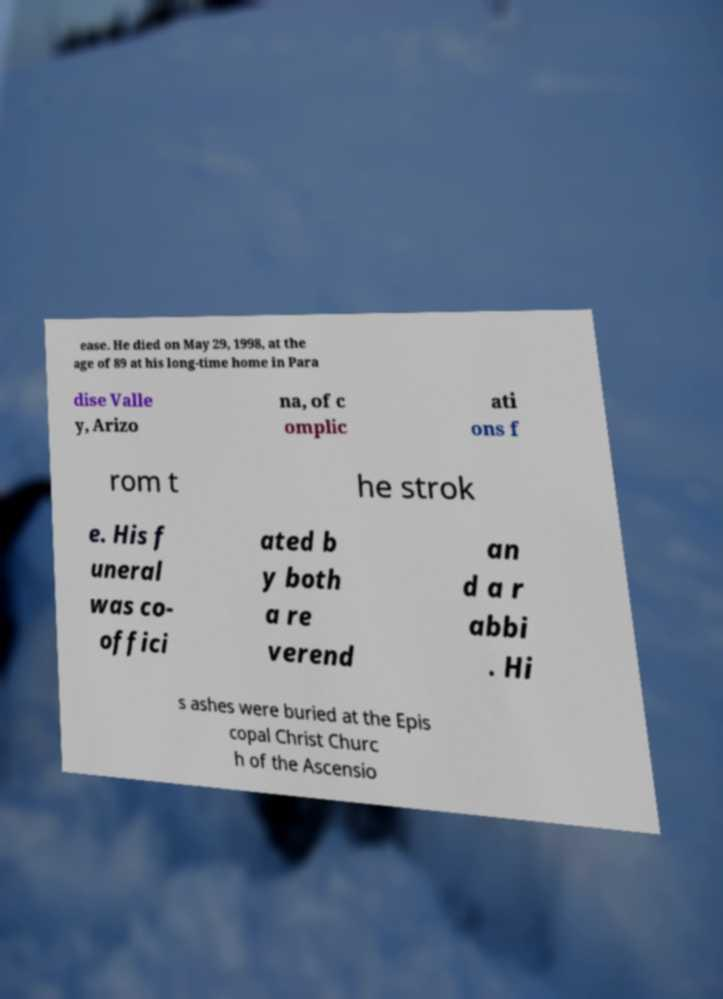Could you assist in decoding the text presented in this image and type it out clearly? ease. He died on May 29, 1998, at the age of 89 at his long-time home in Para dise Valle y, Arizo na, of c omplic ati ons f rom t he strok e. His f uneral was co- offici ated b y both a re verend an d a r abbi . Hi s ashes were buried at the Epis copal Christ Churc h of the Ascensio 